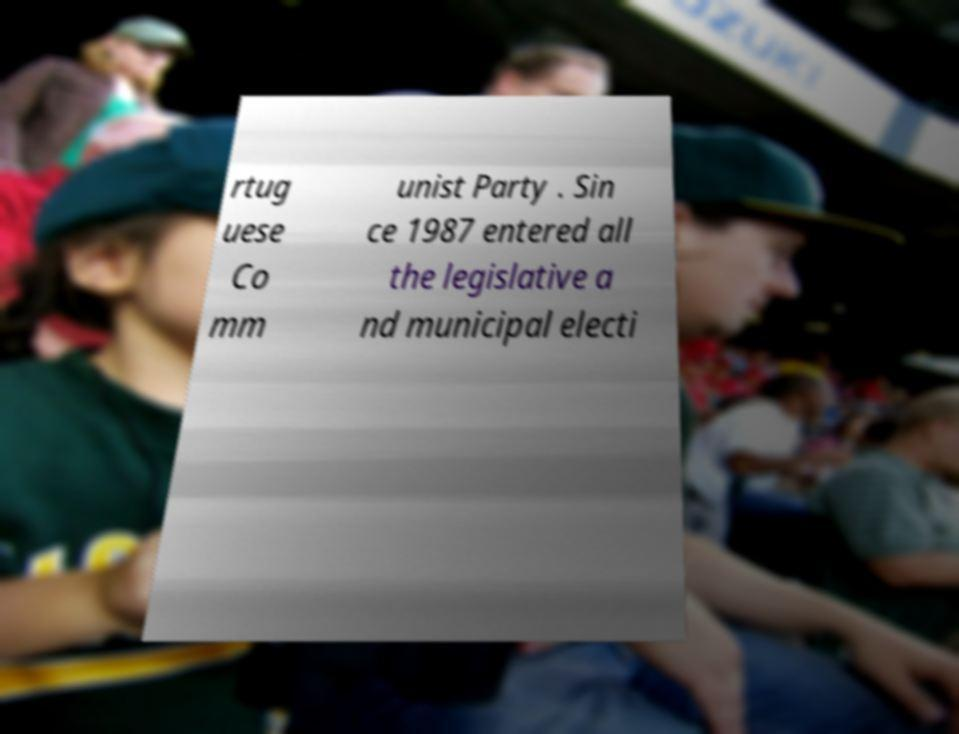I need the written content from this picture converted into text. Can you do that? rtug uese Co mm unist Party . Sin ce 1987 entered all the legislative a nd municipal electi 